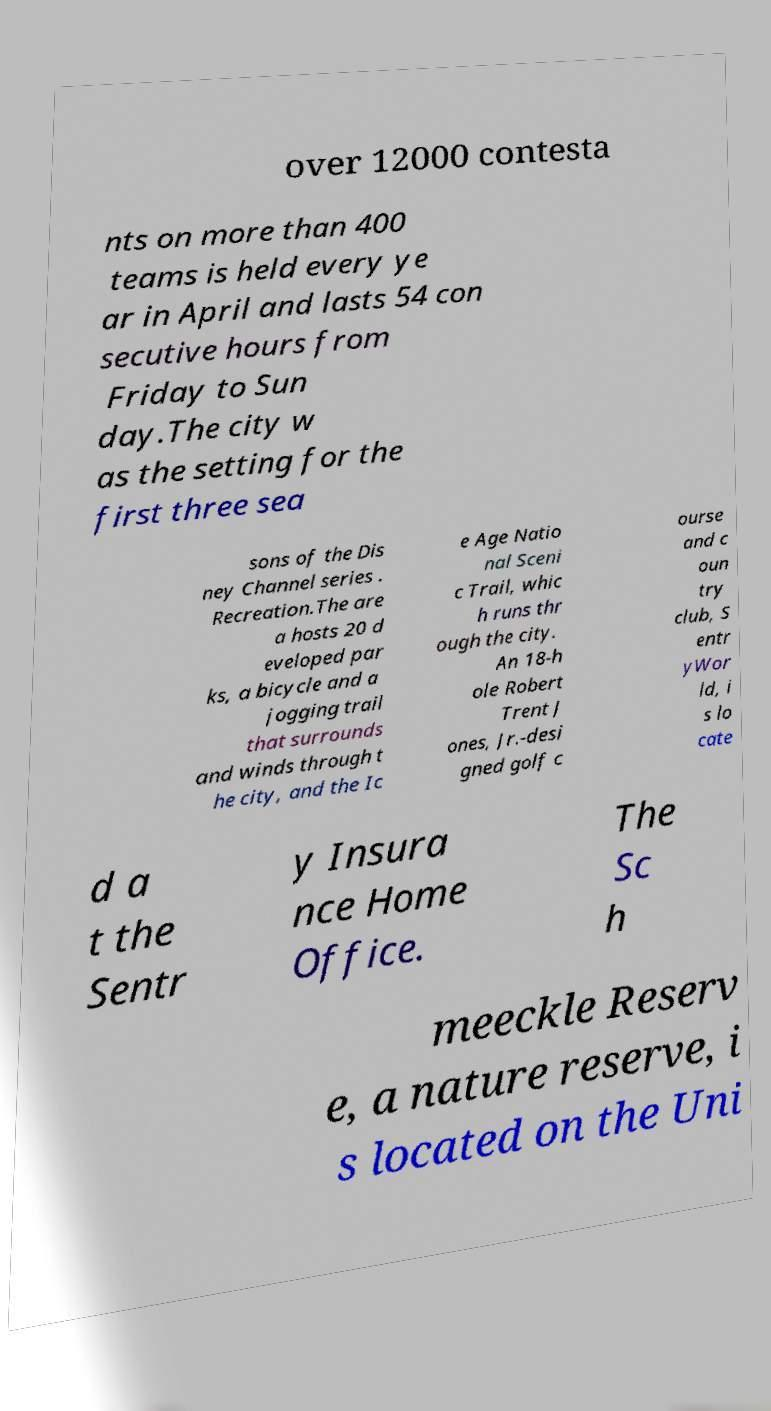Could you assist in decoding the text presented in this image and type it out clearly? over 12000 contesta nts on more than 400 teams is held every ye ar in April and lasts 54 con secutive hours from Friday to Sun day.The city w as the setting for the first three sea sons of the Dis ney Channel series . Recreation.The are a hosts 20 d eveloped par ks, a bicycle and a jogging trail that surrounds and winds through t he city, and the Ic e Age Natio nal Sceni c Trail, whic h runs thr ough the city. An 18-h ole Robert Trent J ones, Jr.-desi gned golf c ourse and c oun try club, S entr yWor ld, i s lo cate d a t the Sentr y Insura nce Home Office. The Sc h meeckle Reserv e, a nature reserve, i s located on the Uni 